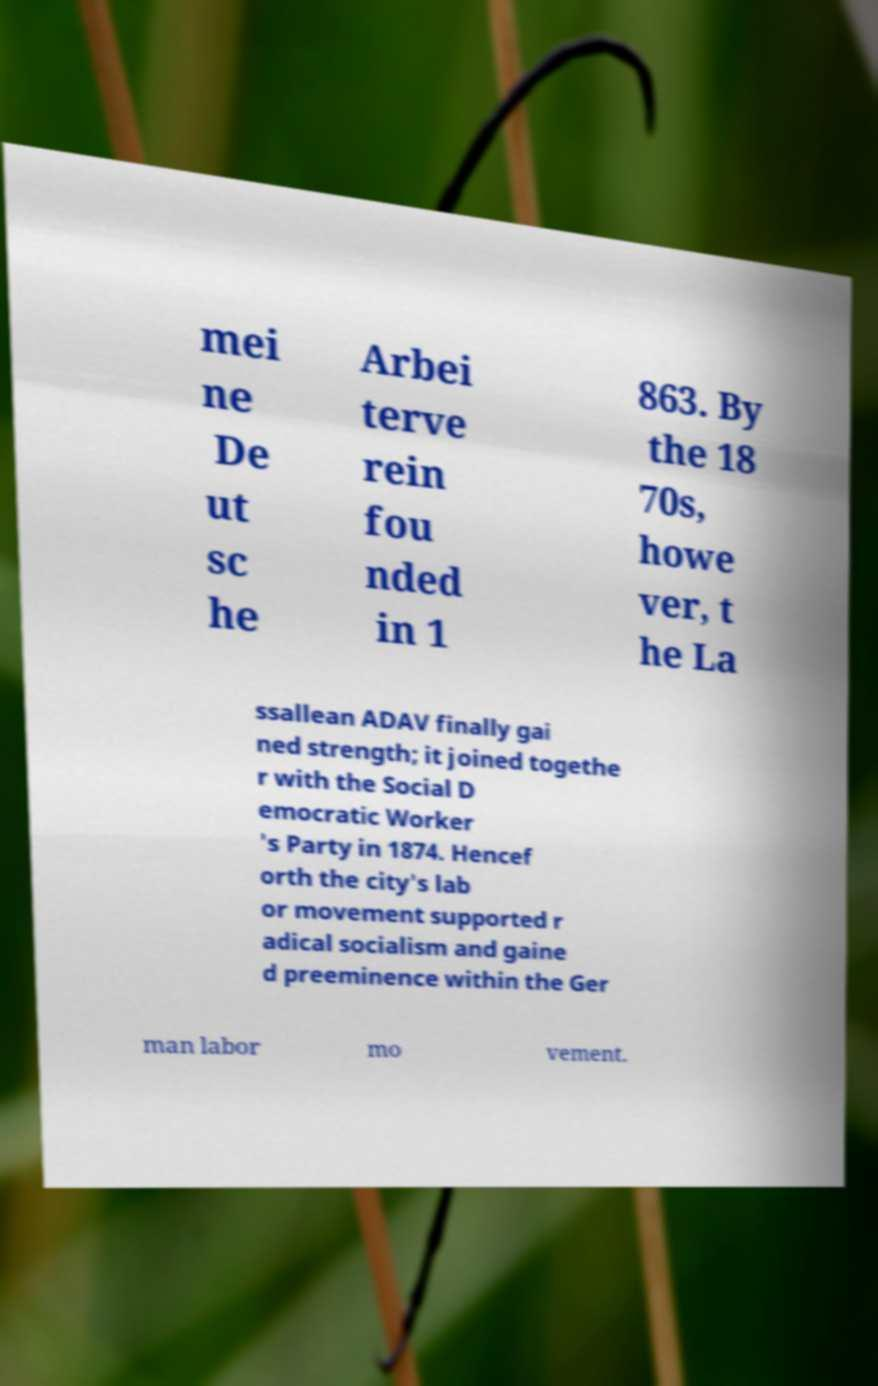For documentation purposes, I need the text within this image transcribed. Could you provide that? mei ne De ut sc he Arbei terve rein fou nded in 1 863. By the 18 70s, howe ver, t he La ssallean ADAV finally gai ned strength; it joined togethe r with the Social D emocratic Worker 's Party in 1874. Hencef orth the city's lab or movement supported r adical socialism and gaine d preeminence within the Ger man labor mo vement. 